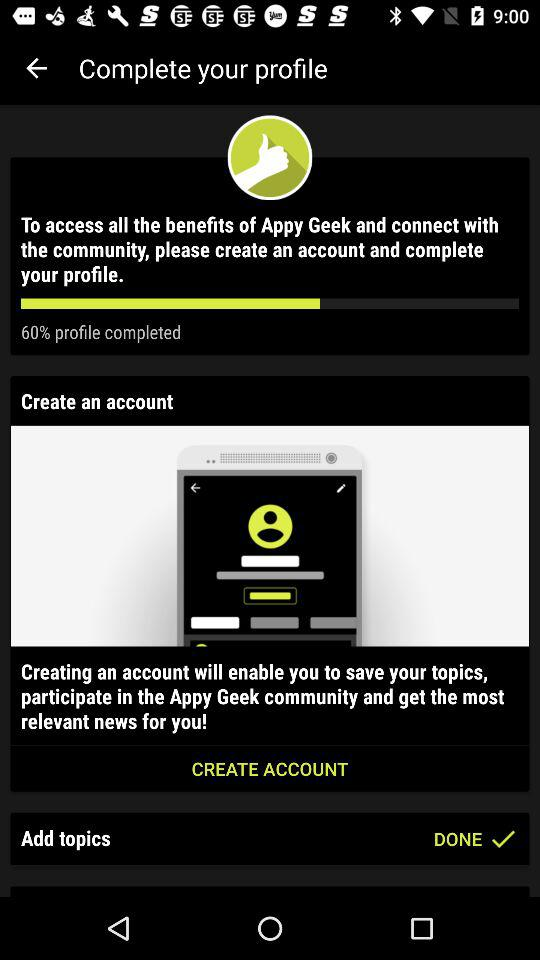How much of the profile is completed? The profile is 60% complete. 